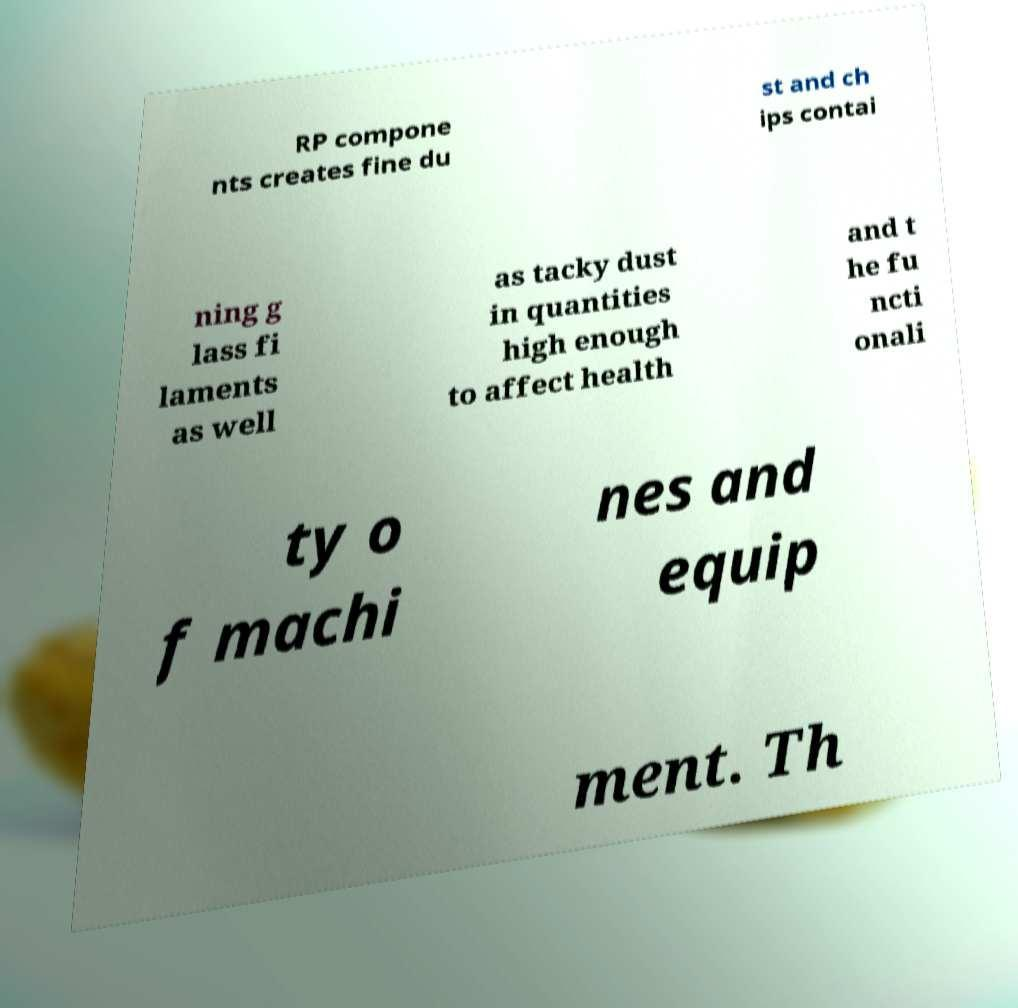There's text embedded in this image that I need extracted. Can you transcribe it verbatim? RP compone nts creates fine du st and ch ips contai ning g lass fi laments as well as tacky dust in quantities high enough to affect health and t he fu ncti onali ty o f machi nes and equip ment. Th 